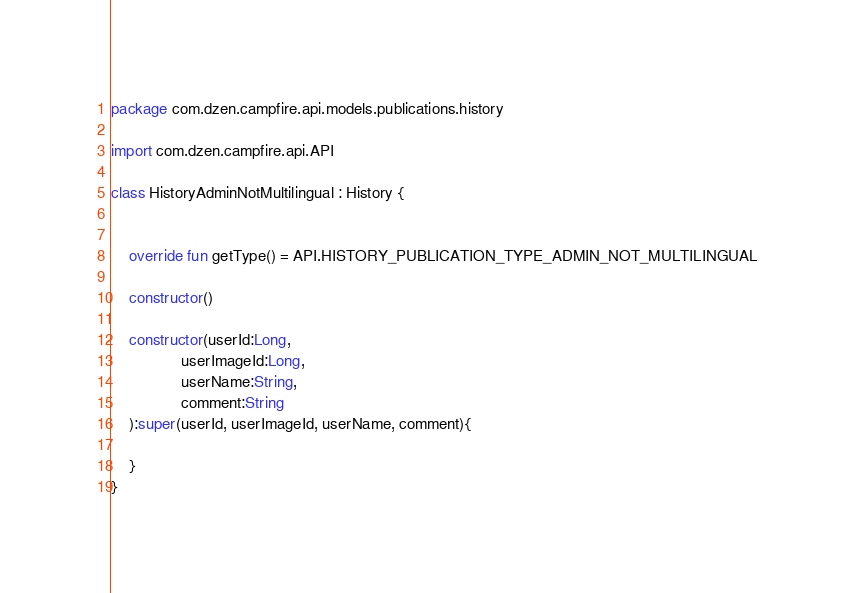Convert code to text. <code><loc_0><loc_0><loc_500><loc_500><_Kotlin_>package com.dzen.campfire.api.models.publications.history

import com.dzen.campfire.api.API

class HistoryAdminNotMultilingual : History {


    override fun getType() = API.HISTORY_PUBLICATION_TYPE_ADMIN_NOT_MULTILINGUAL

    constructor()

    constructor(userId:Long,
                userImageId:Long,
                userName:String,
                comment:String
    ):super(userId, userImageId, userName, comment){

    }
}</code> 